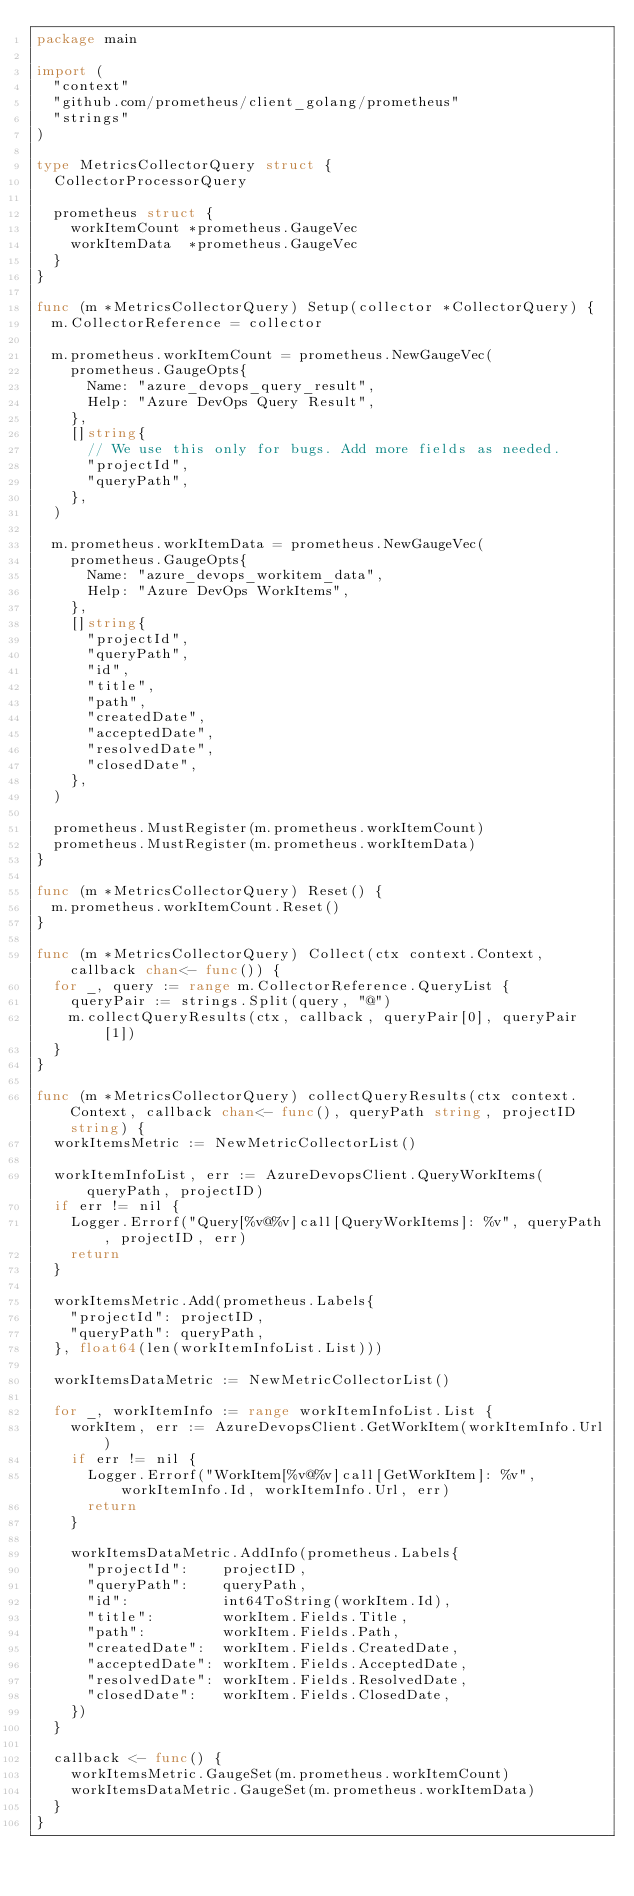Convert code to text. <code><loc_0><loc_0><loc_500><loc_500><_Go_>package main

import (
	"context"
	"github.com/prometheus/client_golang/prometheus"
	"strings"
)

type MetricsCollectorQuery struct {
	CollectorProcessorQuery

	prometheus struct {
		workItemCount *prometheus.GaugeVec
		workItemData  *prometheus.GaugeVec
	}
}

func (m *MetricsCollectorQuery) Setup(collector *CollectorQuery) {
	m.CollectorReference = collector

	m.prometheus.workItemCount = prometheus.NewGaugeVec(
		prometheus.GaugeOpts{
			Name: "azure_devops_query_result",
			Help: "Azure DevOps Query Result",
		},
		[]string{
			// We use this only for bugs. Add more fields as needed.
			"projectId",
			"queryPath",
		},
	)

	m.prometheus.workItemData = prometheus.NewGaugeVec(
		prometheus.GaugeOpts{
			Name: "azure_devops_workitem_data",
			Help: "Azure DevOps WorkItems",
		},
		[]string{
			"projectId",
			"queryPath",
			"id",
			"title",
			"path",
			"createdDate",
			"acceptedDate",
			"resolvedDate",
			"closedDate",
		},
	)

	prometheus.MustRegister(m.prometheus.workItemCount)
	prometheus.MustRegister(m.prometheus.workItemData)
}

func (m *MetricsCollectorQuery) Reset() {
	m.prometheus.workItemCount.Reset()
}

func (m *MetricsCollectorQuery) Collect(ctx context.Context, callback chan<- func()) {
	for _, query := range m.CollectorReference.QueryList {
		queryPair := strings.Split(query, "@")
		m.collectQueryResults(ctx, callback, queryPair[0], queryPair[1])
	}
}

func (m *MetricsCollectorQuery) collectQueryResults(ctx context.Context, callback chan<- func(), queryPath string, projectID string) {
	workItemsMetric := NewMetricCollectorList()

	workItemInfoList, err := AzureDevopsClient.QueryWorkItems(queryPath, projectID)
	if err != nil {
		Logger.Errorf("Query[%v@%v]call[QueryWorkItems]: %v", queryPath, projectID, err)
		return
	}

	workItemsMetric.Add(prometheus.Labels{
		"projectId": projectID,
		"queryPath": queryPath,
	}, float64(len(workItemInfoList.List)))

	workItemsDataMetric := NewMetricCollectorList()

	for _, workItemInfo := range workItemInfoList.List {
		workItem, err := AzureDevopsClient.GetWorkItem(workItemInfo.Url)
		if err != nil {
			Logger.Errorf("WorkItem[%v@%v]call[GetWorkItem]: %v", workItemInfo.Id, workItemInfo.Url, err)
			return
		}

		workItemsDataMetric.AddInfo(prometheus.Labels{
			"projectId":    projectID,
			"queryPath":    queryPath,
			"id":           int64ToString(workItem.Id),
			"title":        workItem.Fields.Title,
			"path":         workItem.Fields.Path,
			"createdDate":  workItem.Fields.CreatedDate,
			"acceptedDate": workItem.Fields.AcceptedDate,
			"resolvedDate": workItem.Fields.ResolvedDate,
			"closedDate":   workItem.Fields.ClosedDate,
		})
	}

	callback <- func() {
		workItemsMetric.GaugeSet(m.prometheus.workItemCount)
		workItemsDataMetric.GaugeSet(m.prometheus.workItemData)
	}
}
</code> 